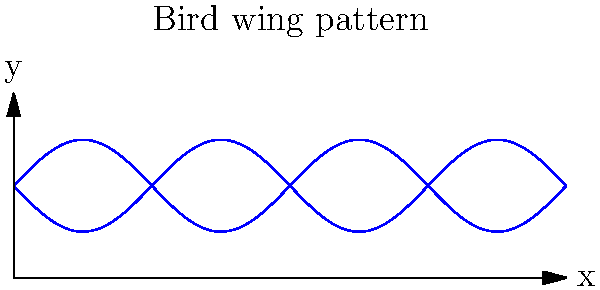A suspension bridge's main cable is designed to mimic a bird's wing pattern, following the equation $y = 0.5 \sin(\frac{2\pi x}{3}) + 1$ for the top curve and $y = -0.5 \sin(\frac{2\pi x}{3}) + 1$ for the bottom curve, where $x$ is the horizontal distance along the bridge (in meters) and $y$ is the height (in meters). If the bridge span is 18 meters, what is the maximum vertical distance between the top and bottom curves? To find the maximum vertical distance between the top and bottom curves, we need to follow these steps:

1. Identify the equations for the top and bottom curves:
   Top curve: $y_1 = 0.5 \sin(\frac{2\pi x}{3}) + 1$
   Bottom curve: $y_2 = -0.5 \sin(\frac{2\pi x}{3}) + 1$

2. Calculate the vertical distance between the curves:
   $d = y_1 - y_2 = [0.5 \sin(\frac{2\pi x}{3}) + 1] - [-0.5 \sin(\frac{2\pi x}{3}) + 1]$
   $d = \sin(\frac{2\pi x}{3})$

3. The maximum value of sine function is 1, which occurs when its argument is $\frac{\pi}{2} + n\pi$, where n is an integer.

4. To find where this maximum occurs:
   $\frac{2\pi x}{3} = \frac{\pi}{2} + n\pi$
   $x = \frac{3}{4} + \frac{3n}{2}$, where $n = 0, 1, 2, ...$

5. The first maximum within the bridge span (18 meters) occurs at $x = \frac{3}{4}$ meters.

6. The maximum vertical distance is when $\sin(\frac{2\pi x}{3}) = 1$, so:
   $d_{max} = 1$ meter

Therefore, the maximum vertical distance between the top and bottom curves is 1 meter.
Answer: 1 meter 